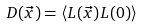<formula> <loc_0><loc_0><loc_500><loc_500>D ( \vec { x } ) = \langle L ( \vec { x } ) L ( 0 ) \rangle</formula> 